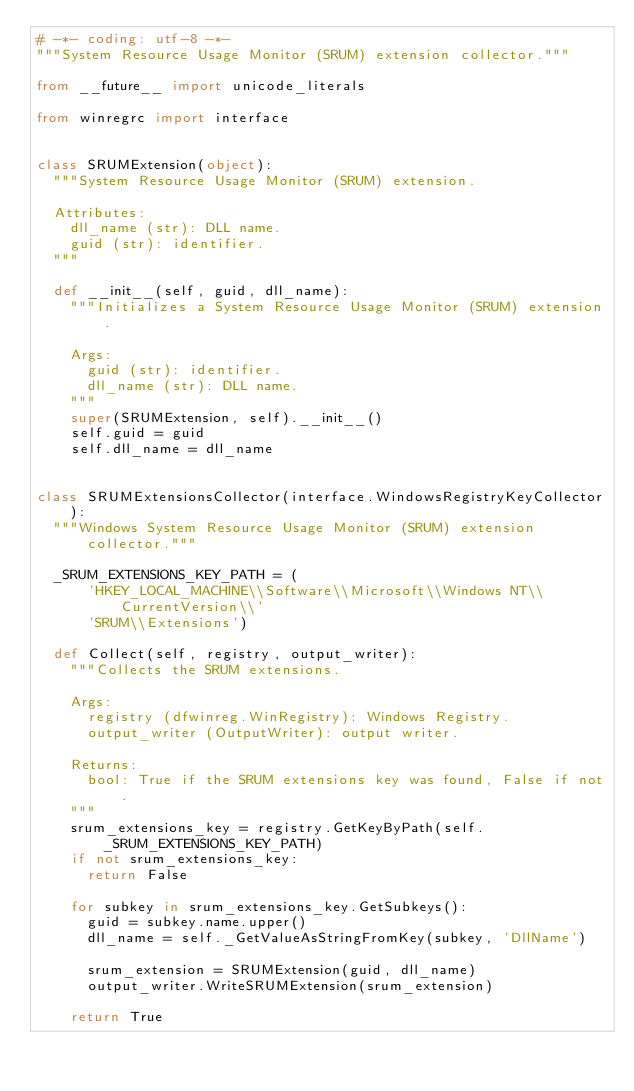<code> <loc_0><loc_0><loc_500><loc_500><_Python_># -*- coding: utf-8 -*-
"""System Resource Usage Monitor (SRUM) extension collector."""

from __future__ import unicode_literals

from winregrc import interface


class SRUMExtension(object):
  """System Resource Usage Monitor (SRUM) extension.

  Attributes:
    dll_name (str): DLL name.
    guid (str): identifier.
  """

  def __init__(self, guid, dll_name):
    """Initializes a System Resource Usage Monitor (SRUM) extension.

    Args:
      guid (str): identifier.
      dll_name (str): DLL name.
    """
    super(SRUMExtension, self).__init__()
    self.guid = guid
    self.dll_name = dll_name


class SRUMExtensionsCollector(interface.WindowsRegistryKeyCollector):
  """Windows System Resource Usage Monitor (SRUM) extension collector."""

  _SRUM_EXTENSIONS_KEY_PATH = (
      'HKEY_LOCAL_MACHINE\\Software\\Microsoft\\Windows NT\\CurrentVersion\\'
      'SRUM\\Extensions')

  def Collect(self, registry, output_writer):
    """Collects the SRUM extensions.

    Args:
      registry (dfwinreg.WinRegistry): Windows Registry.
      output_writer (OutputWriter): output writer.

    Returns:
      bool: True if the SRUM extensions key was found, False if not.
    """
    srum_extensions_key = registry.GetKeyByPath(self._SRUM_EXTENSIONS_KEY_PATH)
    if not srum_extensions_key:
      return False

    for subkey in srum_extensions_key.GetSubkeys():
      guid = subkey.name.upper()
      dll_name = self._GetValueAsStringFromKey(subkey, 'DllName')

      srum_extension = SRUMExtension(guid, dll_name)
      output_writer.WriteSRUMExtension(srum_extension)

    return True
</code> 